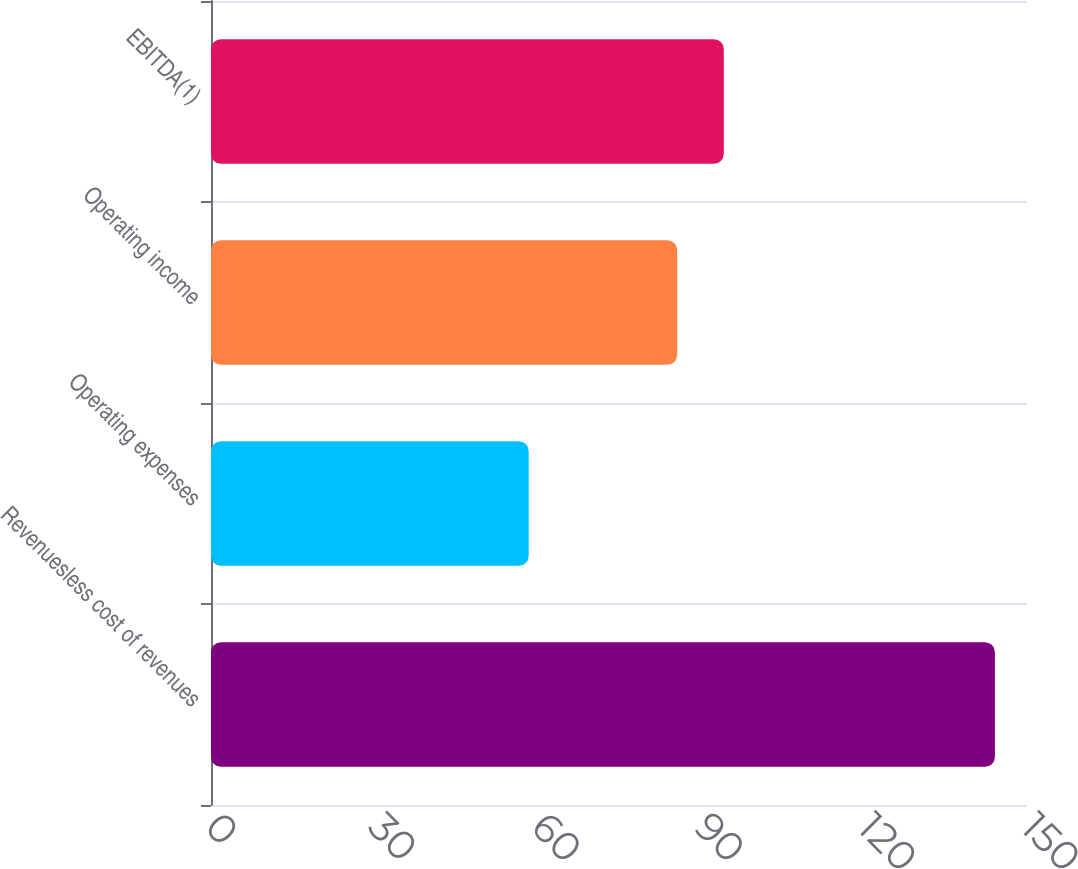<chart> <loc_0><loc_0><loc_500><loc_500><bar_chart><fcel>Revenuesless cost of revenues<fcel>Operating expenses<fcel>Operating income<fcel>EBITDA(1)<nl><fcel>144.1<fcel>58.4<fcel>85.7<fcel>94.27<nl></chart> 